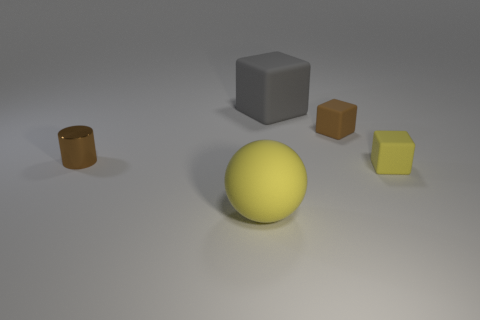What shape is the yellow thing that is on the left side of the big rubber object that is behind the metal object?
Your answer should be very brief. Sphere. What number of objects are either brown rubber blocks or objects that are to the left of the big gray rubber block?
Offer a terse response. 3. How many other things are there of the same color as the sphere?
Make the answer very short. 1. What number of cyan objects are metal cylinders or small blocks?
Provide a succinct answer. 0. There is a yellow matte thing that is left of the rubber cube in front of the brown metal cylinder; is there a tiny brown cylinder that is on the left side of it?
Your answer should be very brief. Yes. What color is the small rubber cube that is in front of the tiny brown object that is on the left side of the big matte cube?
Provide a succinct answer. Yellow. How many small things are yellow balls or cyan things?
Provide a short and direct response. 0. There is a rubber object that is in front of the brown metal cylinder and right of the big yellow rubber object; what is its color?
Offer a terse response. Yellow. Is the material of the big gray thing the same as the small brown cube?
Your response must be concise. Yes. What shape is the gray thing?
Keep it short and to the point. Cube. 